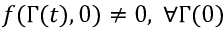Convert formula to latex. <formula><loc_0><loc_0><loc_500><loc_500>f ( \Gamma ( t ) , 0 ) \neq 0 , \, \forall \Gamma ( 0 )</formula> 